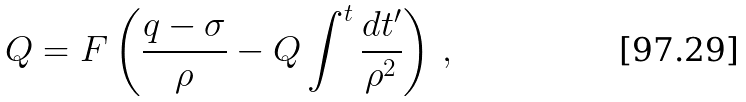Convert formula to latex. <formula><loc_0><loc_0><loc_500><loc_500>Q = F \left ( \frac { q - \sigma } { \rho } - Q \int ^ { t } \frac { d t ^ { \prime } } { \rho ^ { 2 } } \right ) \, ,</formula> 